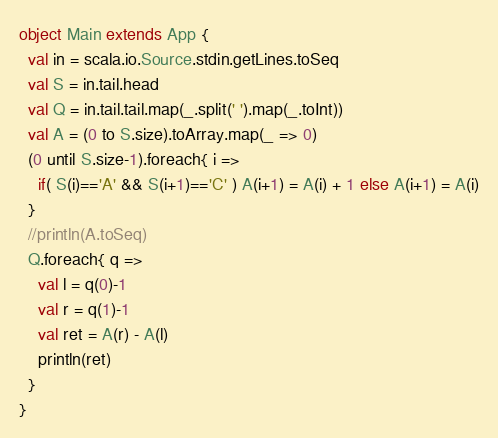Convert code to text. <code><loc_0><loc_0><loc_500><loc_500><_Scala_>object Main extends App {
  val in = scala.io.Source.stdin.getLines.toSeq
  val S = in.tail.head
  val Q = in.tail.tail.map(_.split(' ').map(_.toInt))
  val A = (0 to S.size).toArray.map(_ => 0)
  (0 until S.size-1).foreach{ i =>
    if( S(i)=='A' && S(i+1)=='C' ) A(i+1) = A(i) + 1 else A(i+1) = A(i)
  }
  //println(A.toSeq)
  Q.foreach{ q =>
    val l = q(0)-1
    val r = q(1)-1
    val ret = A(r) - A(l)
    println(ret)
  }
}
</code> 